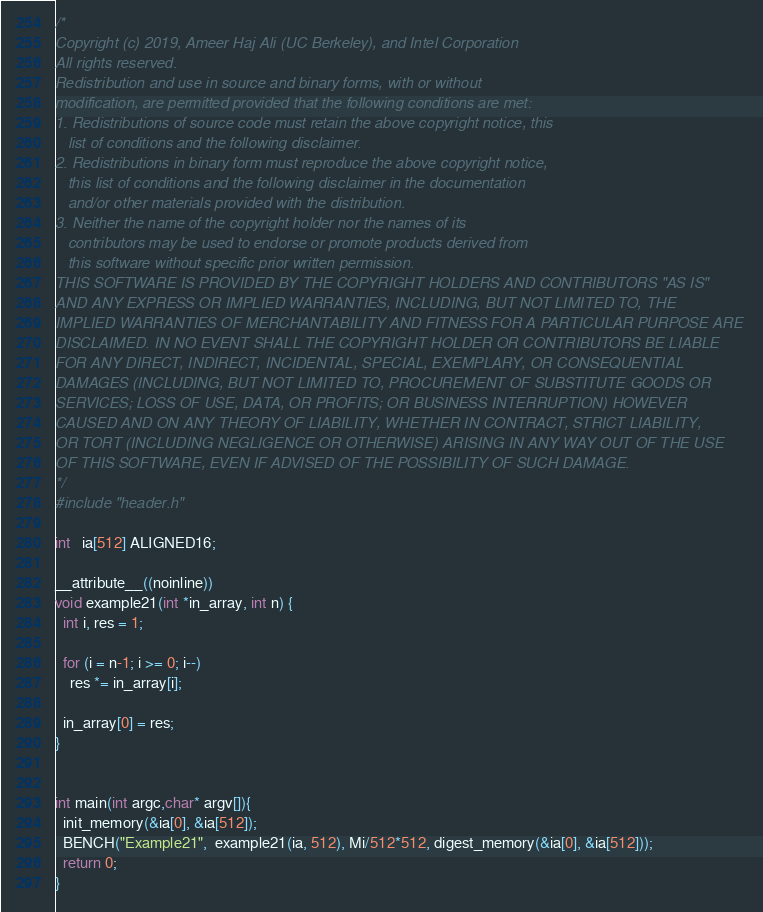Convert code to text. <code><loc_0><loc_0><loc_500><loc_500><_C_>/*
Copyright (c) 2019, Ameer Haj Ali (UC Berkeley), and Intel Corporation
All rights reserved.
Redistribution and use in source and binary forms, with or without
modification, are permitted provided that the following conditions are met:
1. Redistributions of source code must retain the above copyright notice, this
   list of conditions and the following disclaimer.
2. Redistributions in binary form must reproduce the above copyright notice,
   this list of conditions and the following disclaimer in the documentation
   and/or other materials provided with the distribution.
3. Neither the name of the copyright holder nor the names of its
   contributors may be used to endorse or promote products derived from
   this software without specific prior written permission.
THIS SOFTWARE IS PROVIDED BY THE COPYRIGHT HOLDERS AND CONTRIBUTORS "AS IS"
AND ANY EXPRESS OR IMPLIED WARRANTIES, INCLUDING, BUT NOT LIMITED TO, THE
IMPLIED WARRANTIES OF MERCHANTABILITY AND FITNESS FOR A PARTICULAR PURPOSE ARE
DISCLAIMED. IN NO EVENT SHALL THE COPYRIGHT HOLDER OR CONTRIBUTORS BE LIABLE
FOR ANY DIRECT, INDIRECT, INCIDENTAL, SPECIAL, EXEMPLARY, OR CONSEQUENTIAL
DAMAGES (INCLUDING, BUT NOT LIMITED TO, PROCUREMENT OF SUBSTITUTE GOODS OR
SERVICES; LOSS OF USE, DATA, OR PROFITS; OR BUSINESS INTERRUPTION) HOWEVER
CAUSED AND ON ANY THEORY OF LIABILITY, WHETHER IN CONTRACT, STRICT LIABILITY,
OR TORT (INCLUDING NEGLIGENCE OR OTHERWISE) ARISING IN ANY WAY OUT OF THE USE
OF THIS SOFTWARE, EVEN IF ADVISED OF THE POSSIBILITY OF SUCH DAMAGE.
*/
#include "header.h"

int   ia[512] ALIGNED16;

__attribute__((noinline))
void example21(int *in_array, int n) {
  int i, res = 1;

  for (i = n-1; i >= 0; i--)
    res *= in_array[i];

  in_array[0] = res;
}


int main(int argc,char* argv[]){
  init_memory(&ia[0], &ia[512]);
  BENCH("Example21",  example21(ia, 512), Mi/512*512, digest_memory(&ia[0], &ia[512]));
  return 0;
}
</code> 